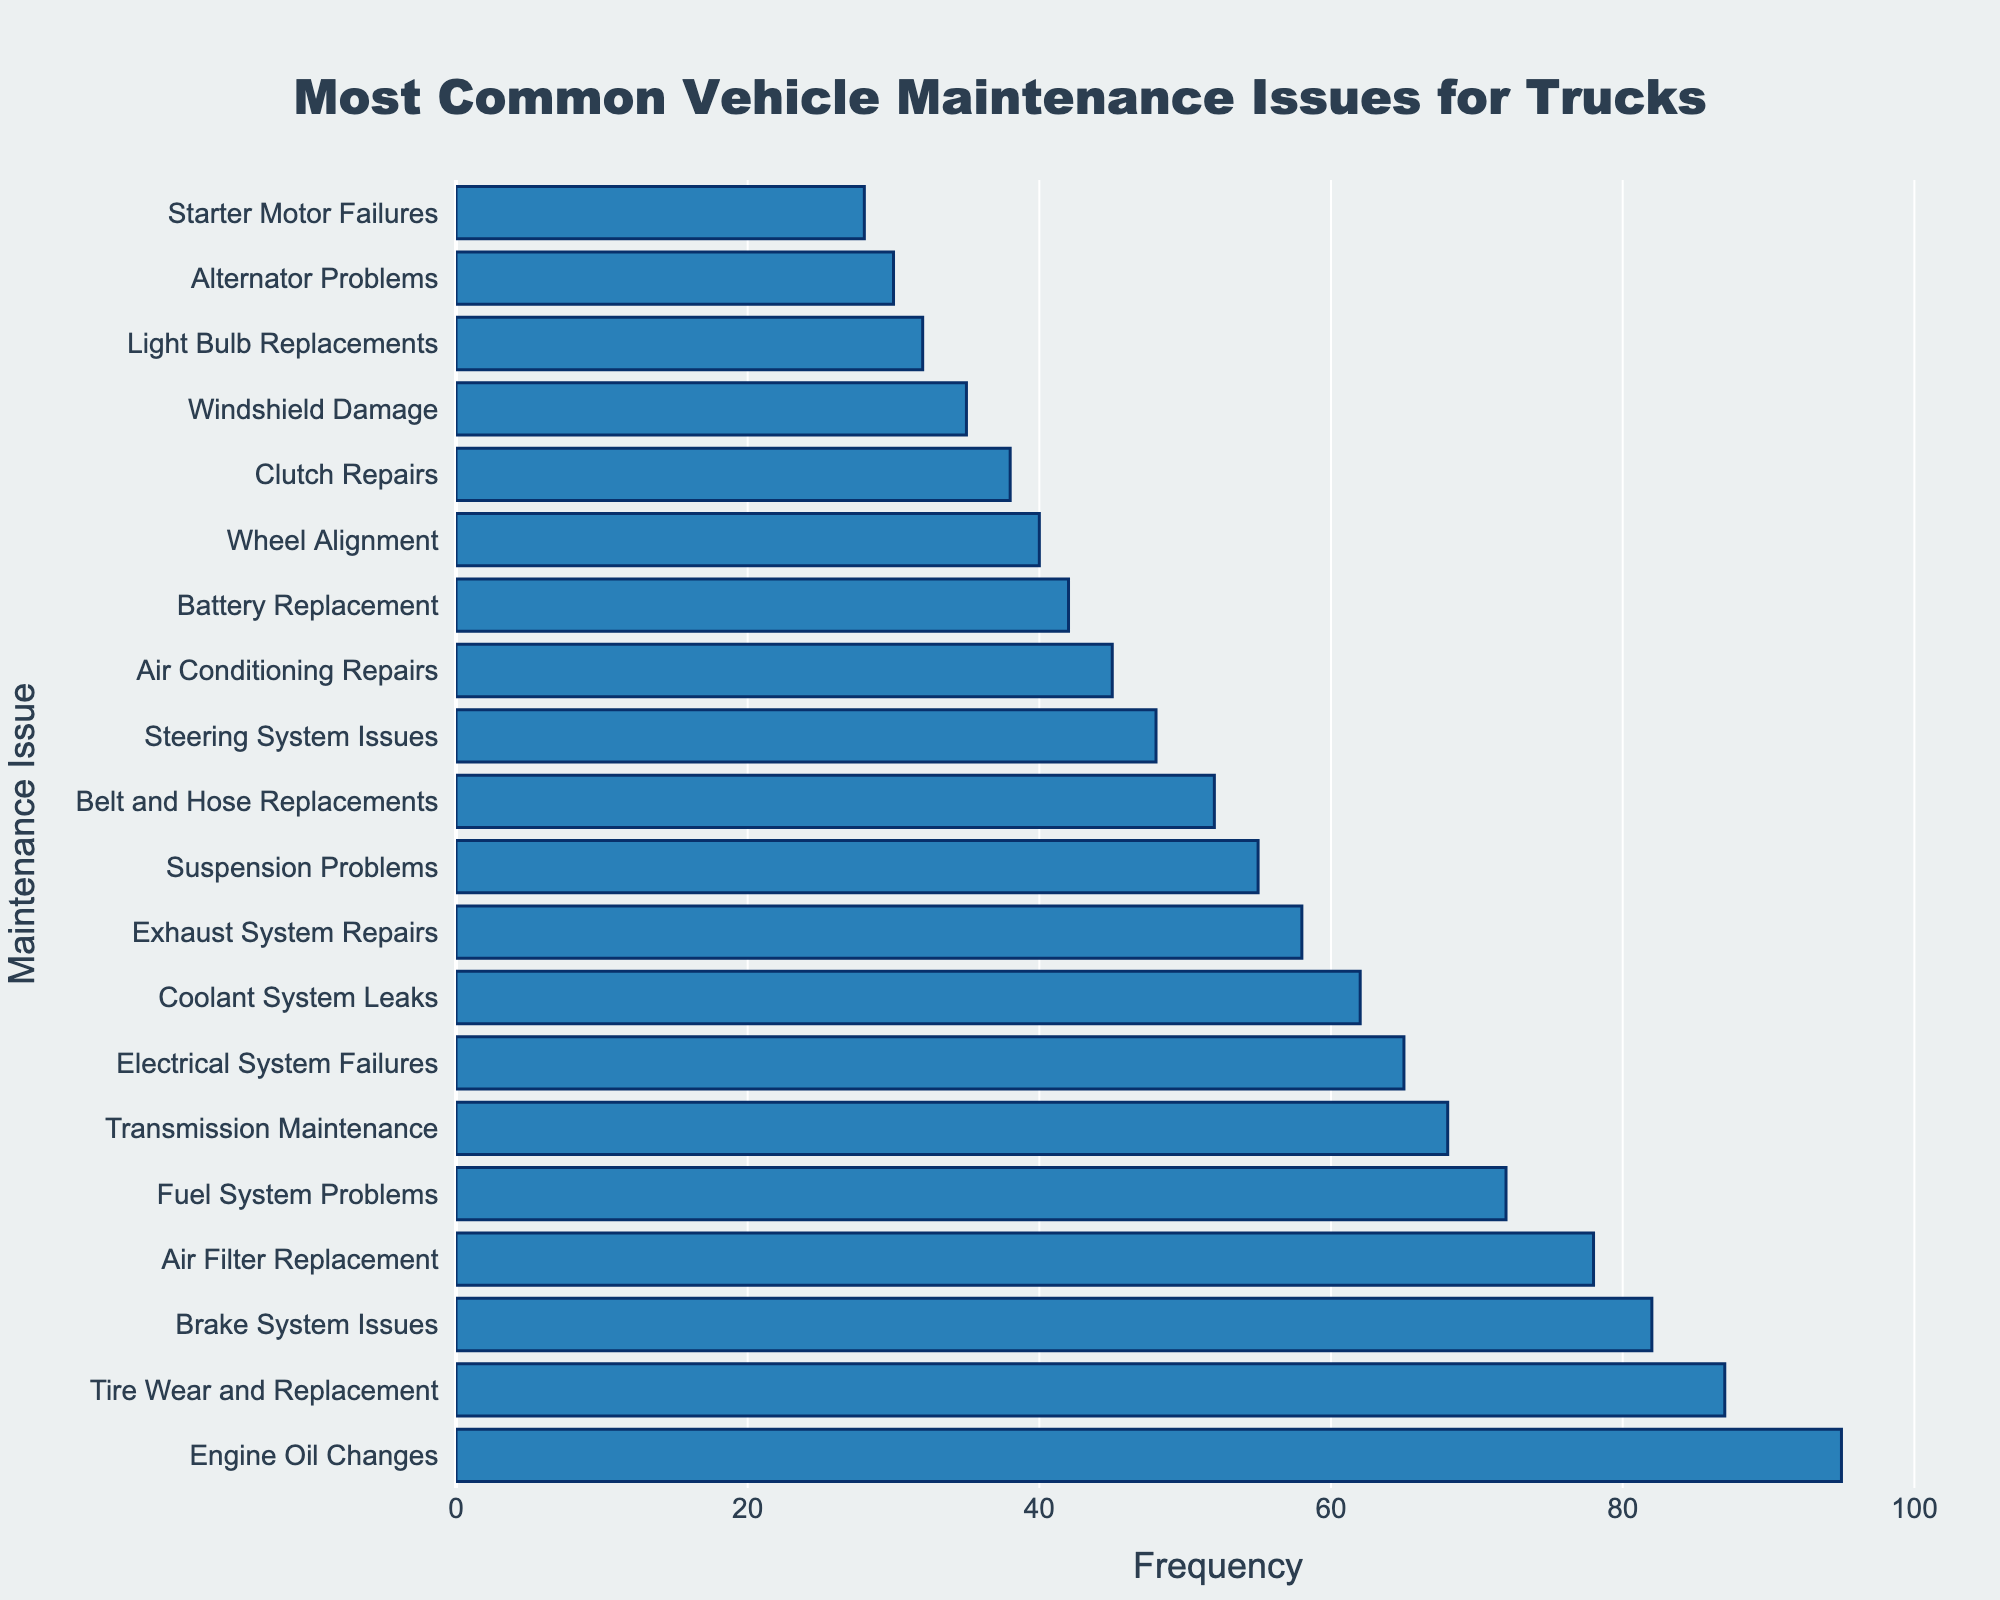Which maintenance issue has the highest frequency? The maintenance issue with the highest frequency is mentioned at the top of the sorted bar chart. It is Engine Oil Changes with a frequency of 95.
Answer: Engine Oil Changes Which maintenance issue has the lowest frequency? The maintenance issue with the lowest frequency is at the bottom of the sorted bar chart. It is Starter Motor Failures with a frequency of 28.
Answer: Starter Motor Failures How many more Engine Oil Changes than Starter Motor Failures are reported? Subtract the frequency of Starter Motor Failures from Engine Oil Changes: 95 - 28 = 67.
Answer: 67 Is the frequency of Brake System Issues greater than or less than the frequency of Tire Wear and Replacement? The frequency of Brake System Issues is 82, which is less than the frequency of Tire Wear and Replacement of 87.
Answer: Less What is the total frequency for the top three maintenance issues? Sum the frequencies of the top three maintenance issues: Engine Oil Changes (95) + Tire Wear and Replacement (87) + Brake System Issues (82) = 264.
Answer: 264 Compare the frequencies of Battery Replacement and Air Conditioning Repairs. Which one is higher and by how much? The frequency of Battery Replacement is 42, and Air Conditioning Repairs is 45. Air Conditioning Repairs has a higher frequency by 3 (45 - 42 = 3).
Answer: Air Conditioning Repairs, 3 What is the average frequency of the maintenance issues listed? Calculate the average by summing all frequencies and dividing by the number of issues: (95 + 87 + 82 + 78 + 72 + 68 + 65 + 62 + 58 + 55 + 52 + 48 + 45 + 42 + 40 + 38 + 35 + 32 + 30 + 28) / 20 = 55.25.
Answer: 55.25 How does the frequency of Electrical System Failures compare to the median frequency of all maintenance issues? Find the median frequency, which is the average of the 10th and 11th values (both are 102 and 104) when sorted in order. The frequency of Electrical System Failures is 65, whereas the median frequency is (55+52)/2 = 53.5.
Answer: Higher, 65 What visual characteristic can you use to identify the bar corresponding to Steering System Issues easily? The bar for Steering System Issues is shorter compared to most other bars and is positioned towards the lower section of the chart with a frequency of 48.
Answer: Shorter bar in the lower section 